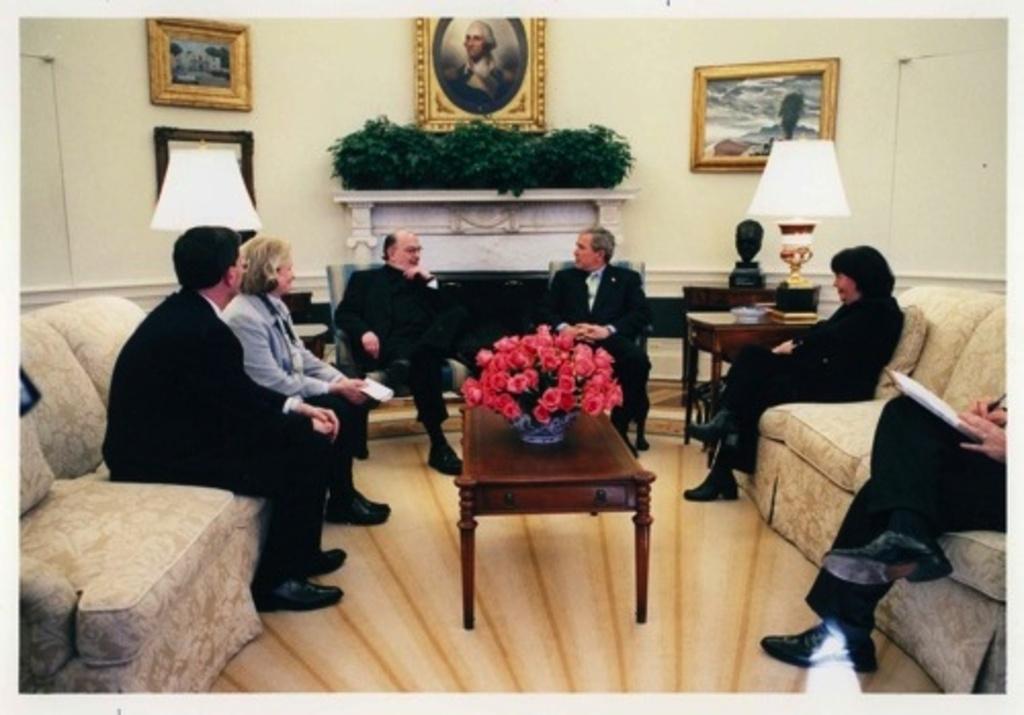Please provide a concise description of this image. In this image there are group of people sitting in the couch and in between them there is table and a flower vase , and in back ground there are plants , lamp, frames , fire place. 